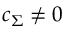Convert formula to latex. <formula><loc_0><loc_0><loc_500><loc_500>c _ { \Sigma } \neq 0</formula> 